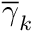<formula> <loc_0><loc_0><loc_500><loc_500>\overline { \gamma } _ { k }</formula> 